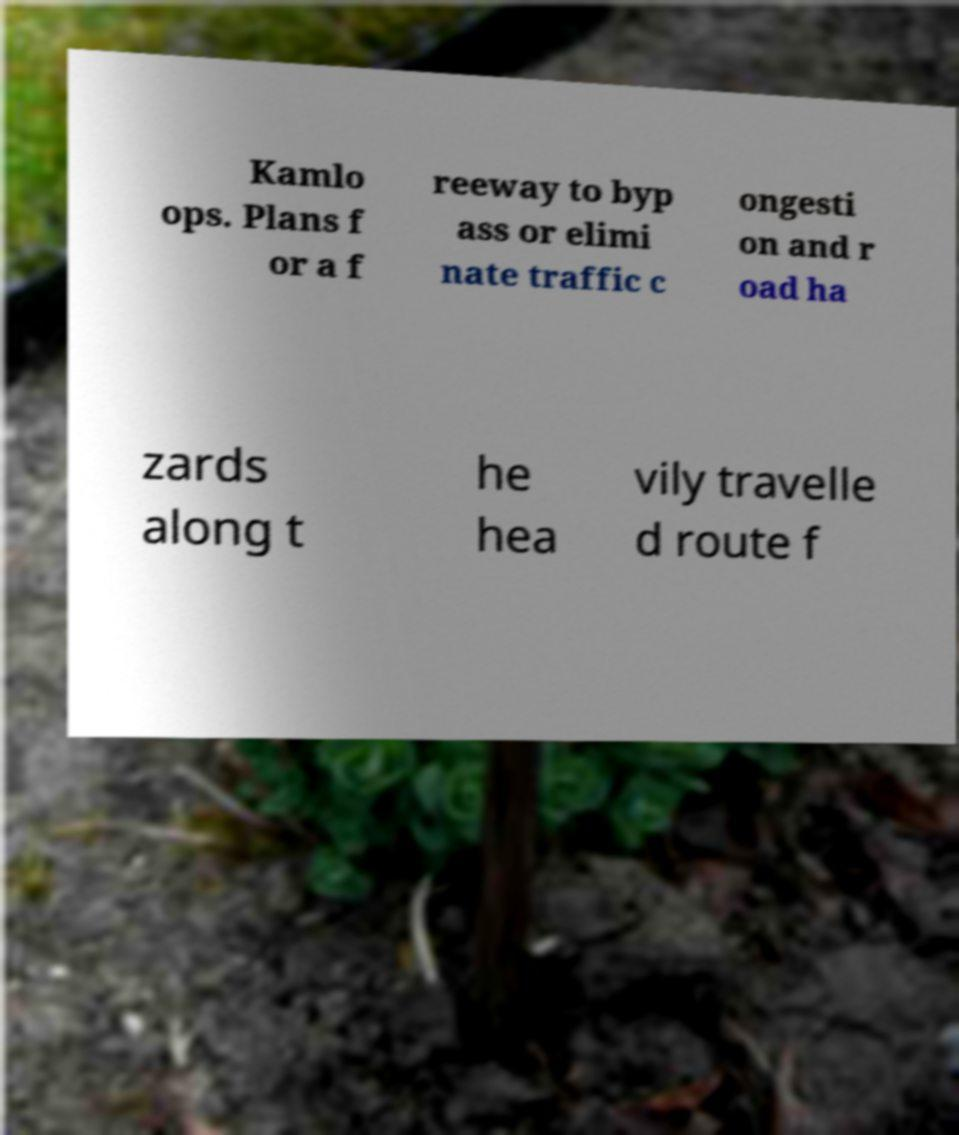Can you accurately transcribe the text from the provided image for me? Kamlo ops. Plans f or a f reeway to byp ass or elimi nate traffic c ongesti on and r oad ha zards along t he hea vily travelle d route f 